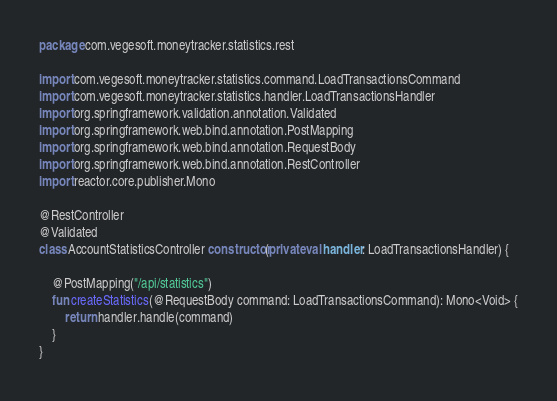Convert code to text. <code><loc_0><loc_0><loc_500><loc_500><_Kotlin_>package com.vegesoft.moneytracker.statistics.rest

import com.vegesoft.moneytracker.statistics.command.LoadTransactionsCommand
import com.vegesoft.moneytracker.statistics.handler.LoadTransactionsHandler
import org.springframework.validation.annotation.Validated
import org.springframework.web.bind.annotation.PostMapping
import org.springframework.web.bind.annotation.RequestBody
import org.springframework.web.bind.annotation.RestController
import reactor.core.publisher.Mono

@RestController
@Validated
class AccountStatisticsController constructor(private val handler: LoadTransactionsHandler) {

    @PostMapping("/api/statistics")
    fun createStatistics(@RequestBody command: LoadTransactionsCommand): Mono<Void> {
        return handler.handle(command)
    }
}</code> 